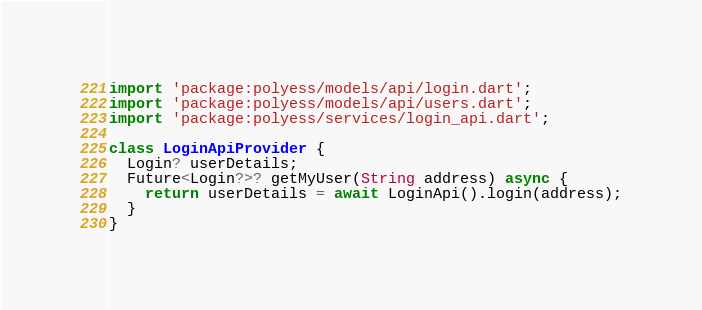Convert code to text. <code><loc_0><loc_0><loc_500><loc_500><_Dart_>import 'package:polyess/models/api/login.dart';
import 'package:polyess/models/api/users.dart';
import 'package:polyess/services/login_api.dart';

class LoginApiProvider {
  Login? userDetails;
  Future<Login?>? getMyUser(String address) async {
    return userDetails = await LoginApi().login(address);
  }
}
</code> 